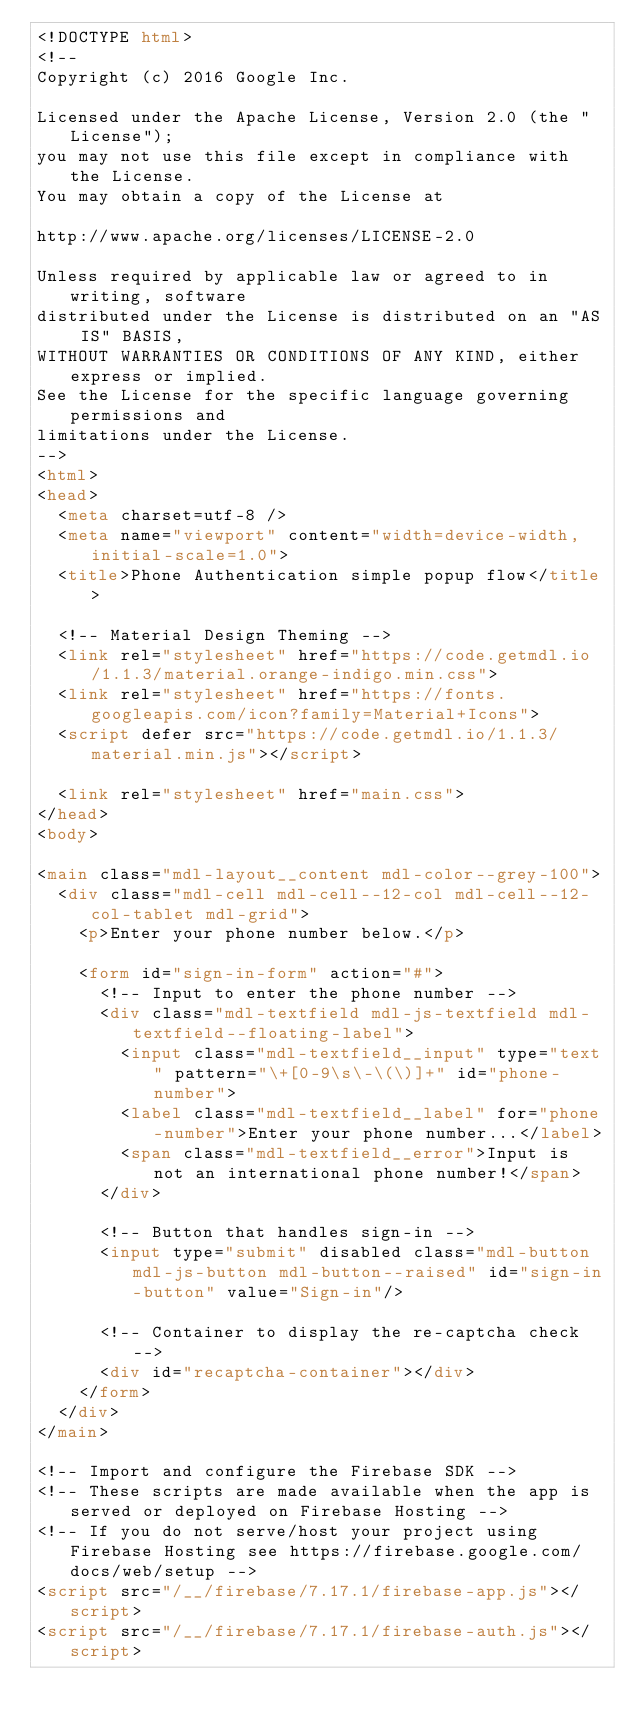<code> <loc_0><loc_0><loc_500><loc_500><_HTML_><!DOCTYPE html>
<!--
Copyright (c) 2016 Google Inc.

Licensed under the Apache License, Version 2.0 (the "License");
you may not use this file except in compliance with the License.
You may obtain a copy of the License at

http://www.apache.org/licenses/LICENSE-2.0

Unless required by applicable law or agreed to in writing, software
distributed under the License is distributed on an "AS IS" BASIS,
WITHOUT WARRANTIES OR CONDITIONS OF ANY KIND, either express or implied.
See the License for the specific language governing permissions and
limitations under the License.
-->
<html>
<head>
  <meta charset=utf-8 />
  <meta name="viewport" content="width=device-width, initial-scale=1.0">
  <title>Phone Authentication simple popup flow</title>

  <!-- Material Design Theming -->
  <link rel="stylesheet" href="https://code.getmdl.io/1.1.3/material.orange-indigo.min.css">
  <link rel="stylesheet" href="https://fonts.googleapis.com/icon?family=Material+Icons">
  <script defer src="https://code.getmdl.io/1.1.3/material.min.js"></script>

  <link rel="stylesheet" href="main.css">
</head>
<body>

<main class="mdl-layout__content mdl-color--grey-100">
  <div class="mdl-cell mdl-cell--12-col mdl-cell--12-col-tablet mdl-grid">
    <p>Enter your phone number below.</p>

    <form id="sign-in-form" action="#">
      <!-- Input to enter the phone number -->
      <div class="mdl-textfield mdl-js-textfield mdl-textfield--floating-label">
        <input class="mdl-textfield__input" type="text" pattern="\+[0-9\s\-\(\)]+" id="phone-number">
        <label class="mdl-textfield__label" for="phone-number">Enter your phone number...</label>
        <span class="mdl-textfield__error">Input is not an international phone number!</span>
      </div>

      <!-- Button that handles sign-in -->
      <input type="submit" disabled class="mdl-button mdl-js-button mdl-button--raised" id="sign-in-button" value="Sign-in"/>

      <!-- Container to display the re-captcha check -->
      <div id="recaptcha-container"></div>
    </form>
  </div>
</main>

<!-- Import and configure the Firebase SDK -->
<!-- These scripts are made available when the app is served or deployed on Firebase Hosting -->
<!-- If you do not serve/host your project using Firebase Hosting see https://firebase.google.com/docs/web/setup -->
<script src="/__/firebase/7.17.1/firebase-app.js"></script>
<script src="/__/firebase/7.17.1/firebase-auth.js"></script></code> 